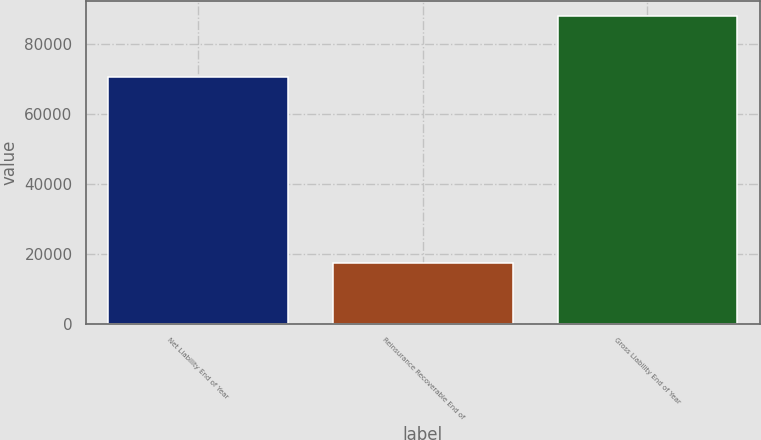<chart> <loc_0><loc_0><loc_500><loc_500><bar_chart><fcel>Net Liability End of Year<fcel>Reinsurance Recoverable End of<fcel>Gross Liability End of Year<nl><fcel>70554<fcel>17487<fcel>88041<nl></chart> 